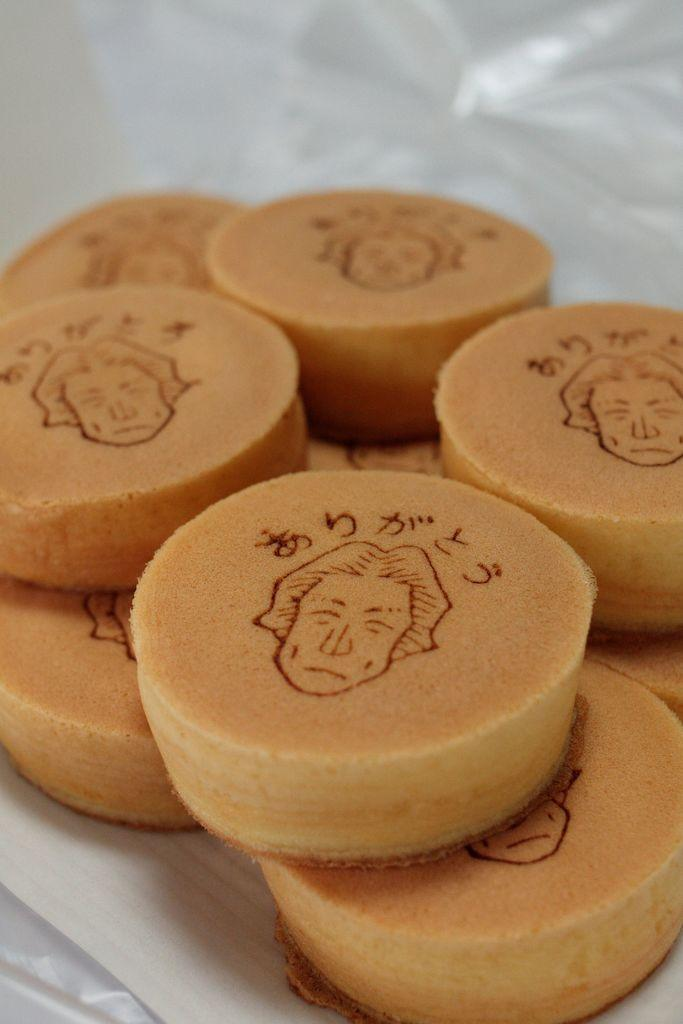What type of food can be seen in the image? There are eatables in the image that resemble cakes. What color is the background of the image? The background of the image is white in color. Can you describe any objects on the table in the image? There might be a sheet placed on the table in the image. How many shoes are visible in the image? There are no shoes present in the image. What type of farm equipment can be seen in the image? There is no farm equipment, such as a rake, present in the image. 